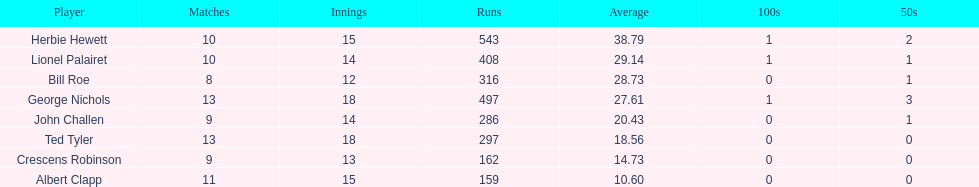How many innings did bill and ted have in total? 30. 